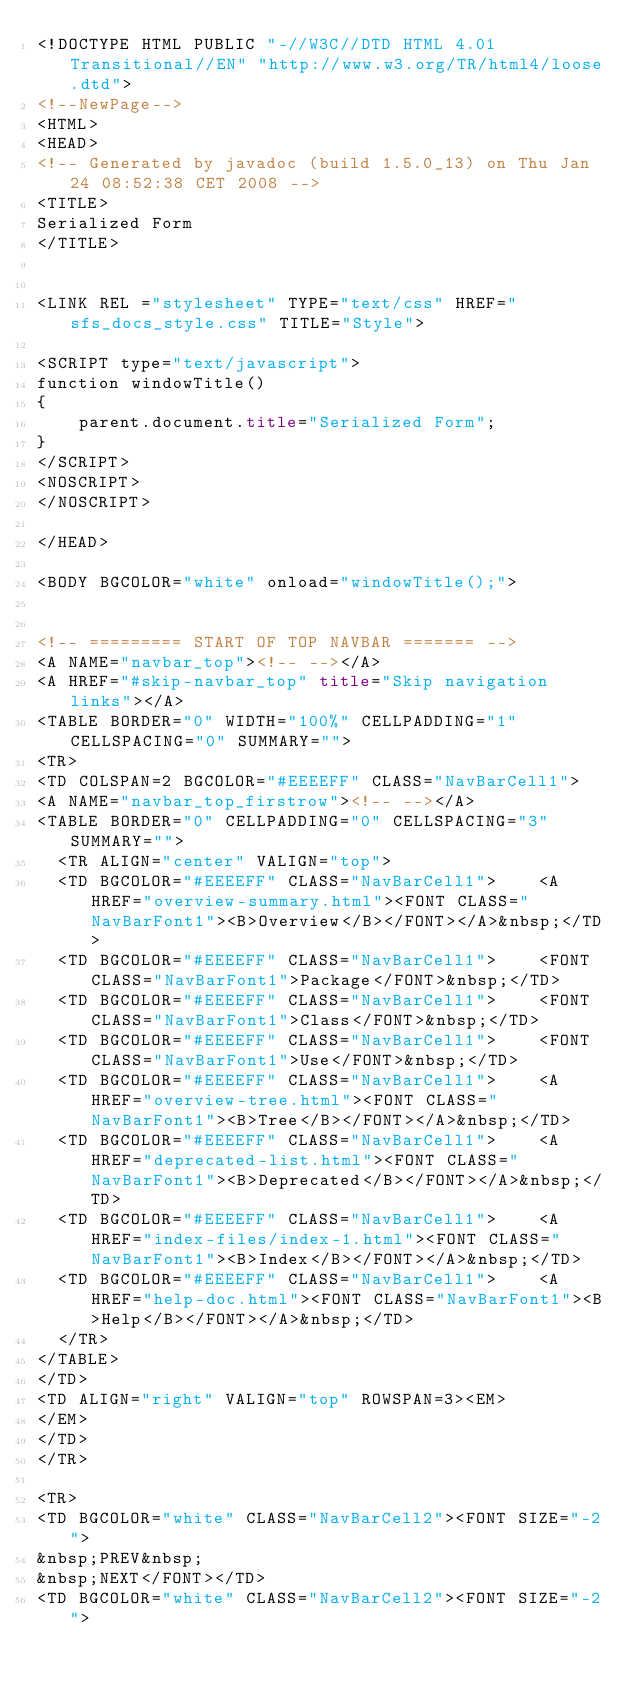<code> <loc_0><loc_0><loc_500><loc_500><_HTML_><!DOCTYPE HTML PUBLIC "-//W3C//DTD HTML 4.01 Transitional//EN" "http://www.w3.org/TR/html4/loose.dtd">
<!--NewPage-->
<HTML>
<HEAD>
<!-- Generated by javadoc (build 1.5.0_13) on Thu Jan 24 08:52:38 CET 2008 -->
<TITLE>
Serialized Form
</TITLE>


<LINK REL ="stylesheet" TYPE="text/css" HREF="sfs_docs_style.css" TITLE="Style">

<SCRIPT type="text/javascript">
function windowTitle()
{
    parent.document.title="Serialized Form";
}
</SCRIPT>
<NOSCRIPT>
</NOSCRIPT>

</HEAD>

<BODY BGCOLOR="white" onload="windowTitle();">


<!-- ========= START OF TOP NAVBAR ======= -->
<A NAME="navbar_top"><!-- --></A>
<A HREF="#skip-navbar_top" title="Skip navigation links"></A>
<TABLE BORDER="0" WIDTH="100%" CELLPADDING="1" CELLSPACING="0" SUMMARY="">
<TR>
<TD COLSPAN=2 BGCOLOR="#EEEEFF" CLASS="NavBarCell1">
<A NAME="navbar_top_firstrow"><!-- --></A>
<TABLE BORDER="0" CELLPADDING="0" CELLSPACING="3" SUMMARY="">
  <TR ALIGN="center" VALIGN="top">
  <TD BGCOLOR="#EEEEFF" CLASS="NavBarCell1">    <A HREF="overview-summary.html"><FONT CLASS="NavBarFont1"><B>Overview</B></FONT></A>&nbsp;</TD>
  <TD BGCOLOR="#EEEEFF" CLASS="NavBarCell1">    <FONT CLASS="NavBarFont1">Package</FONT>&nbsp;</TD>
  <TD BGCOLOR="#EEEEFF" CLASS="NavBarCell1">    <FONT CLASS="NavBarFont1">Class</FONT>&nbsp;</TD>
  <TD BGCOLOR="#EEEEFF" CLASS="NavBarCell1">    <FONT CLASS="NavBarFont1">Use</FONT>&nbsp;</TD>
  <TD BGCOLOR="#EEEEFF" CLASS="NavBarCell1">    <A HREF="overview-tree.html"><FONT CLASS="NavBarFont1"><B>Tree</B></FONT></A>&nbsp;</TD>
  <TD BGCOLOR="#EEEEFF" CLASS="NavBarCell1">    <A HREF="deprecated-list.html"><FONT CLASS="NavBarFont1"><B>Deprecated</B></FONT></A>&nbsp;</TD>
  <TD BGCOLOR="#EEEEFF" CLASS="NavBarCell1">    <A HREF="index-files/index-1.html"><FONT CLASS="NavBarFont1"><B>Index</B></FONT></A>&nbsp;</TD>
  <TD BGCOLOR="#EEEEFF" CLASS="NavBarCell1">    <A HREF="help-doc.html"><FONT CLASS="NavBarFont1"><B>Help</B></FONT></A>&nbsp;</TD>
  </TR>
</TABLE>
</TD>
<TD ALIGN="right" VALIGN="top" ROWSPAN=3><EM>
</EM>
</TD>
</TR>

<TR>
<TD BGCOLOR="white" CLASS="NavBarCell2"><FONT SIZE="-2">
&nbsp;PREV&nbsp;
&nbsp;NEXT</FONT></TD>
<TD BGCOLOR="white" CLASS="NavBarCell2"><FONT SIZE="-2"></code> 